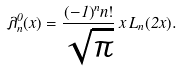Convert formula to latex. <formula><loc_0><loc_0><loc_500><loc_500>\lambda ^ { 0 } _ { n } ( x ) = \frac { ( - 1 ) ^ { n } n ! } { \sqrt { \pi } } \, x \, L _ { n } ( 2 x ) .</formula> 